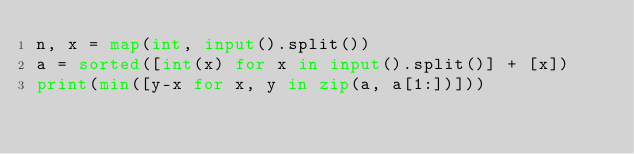<code> <loc_0><loc_0><loc_500><loc_500><_Python_>n, x = map(int, input().split())
a = sorted([int(x) for x in input().split()] + [x])
print(min([y-x for x, y in zip(a, a[1:])])) </code> 